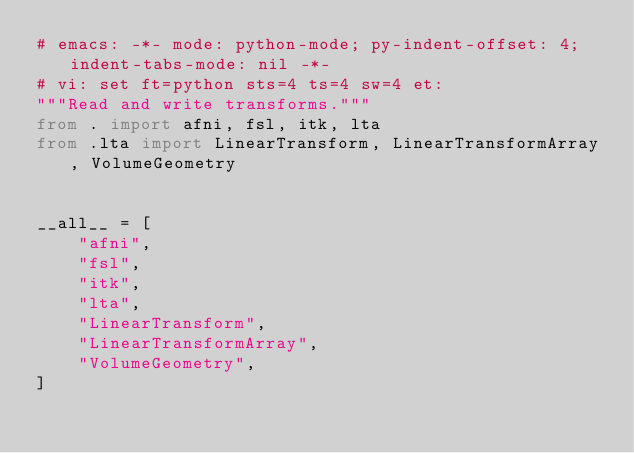<code> <loc_0><loc_0><loc_500><loc_500><_Python_># emacs: -*- mode: python-mode; py-indent-offset: 4; indent-tabs-mode: nil -*-
# vi: set ft=python sts=4 ts=4 sw=4 et:
"""Read and write transforms."""
from . import afni, fsl, itk, lta
from .lta import LinearTransform, LinearTransformArray, VolumeGeometry


__all__ = [
    "afni",
    "fsl",
    "itk",
    "lta",
    "LinearTransform",
    "LinearTransformArray",
    "VolumeGeometry",
]
</code> 